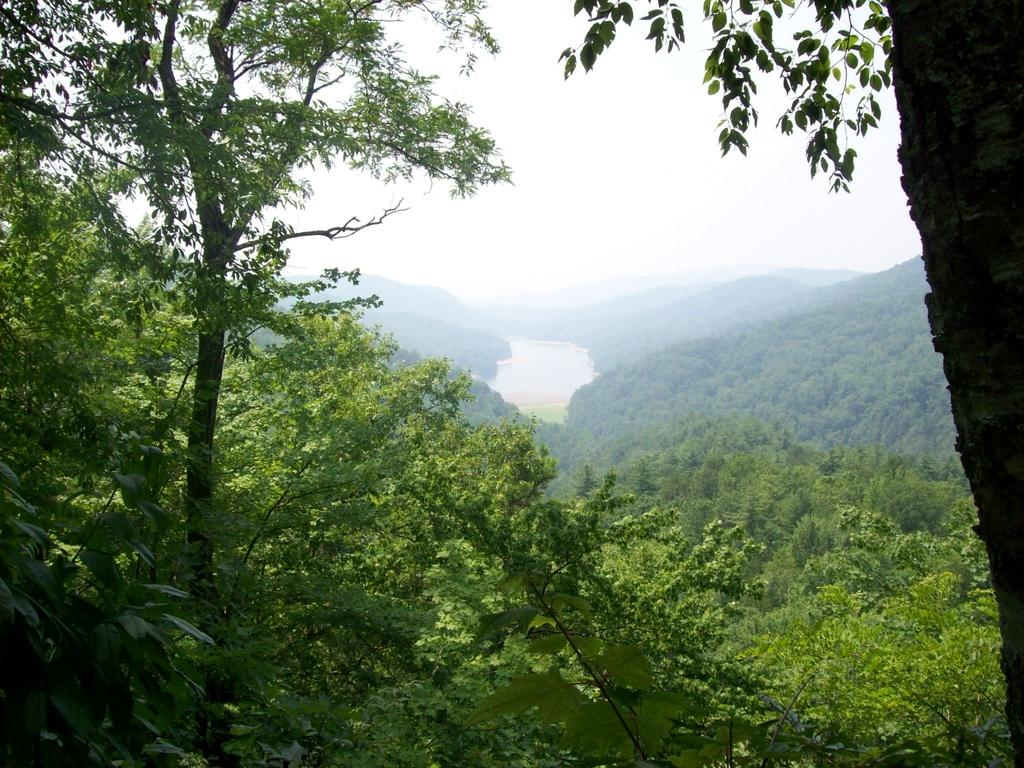What type of vegetation can be seen in the image? There are trees in the image. What natural element is visible alongside the trees? There is water visible in the image. What part of the natural environment is visible in the image? The sky is visible in the image. What type of songs can be heard coming from the trees in the image? There are no songs present in the image, as trees do not produce or play music. 